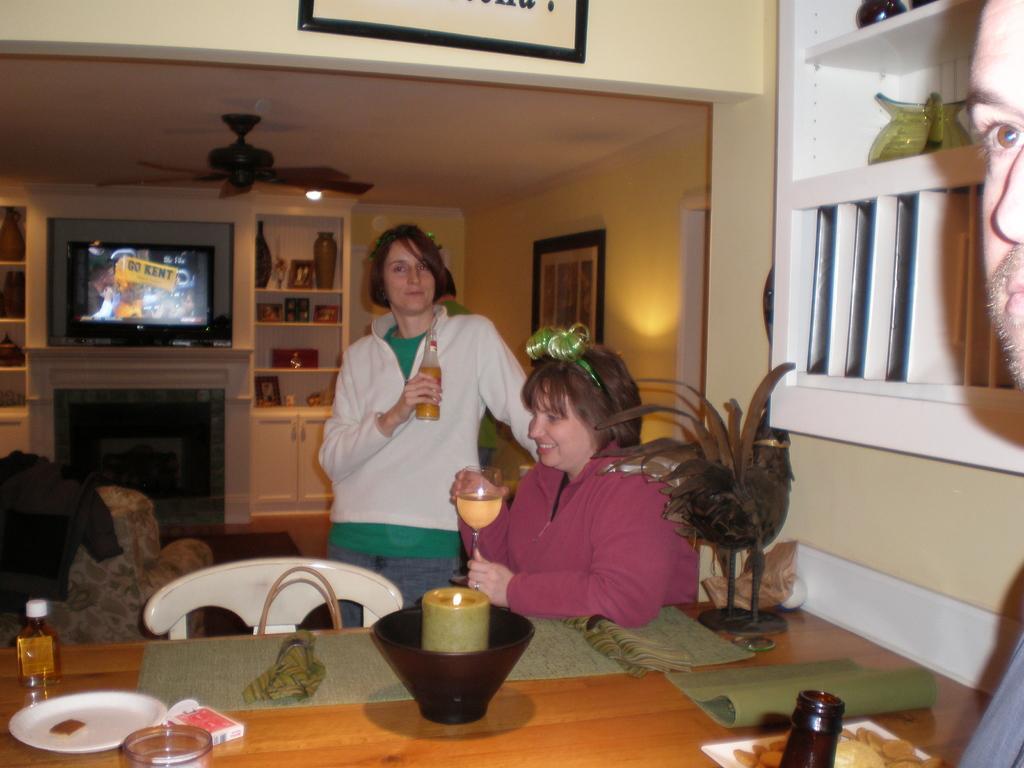Could you give a brief overview of what you see in this image? As we can see in the image, there are two persons. In front of these persons there is a table. On table there is a bottle, plate and a plant. Behind them there is a wall and shelves, tv and fan. 